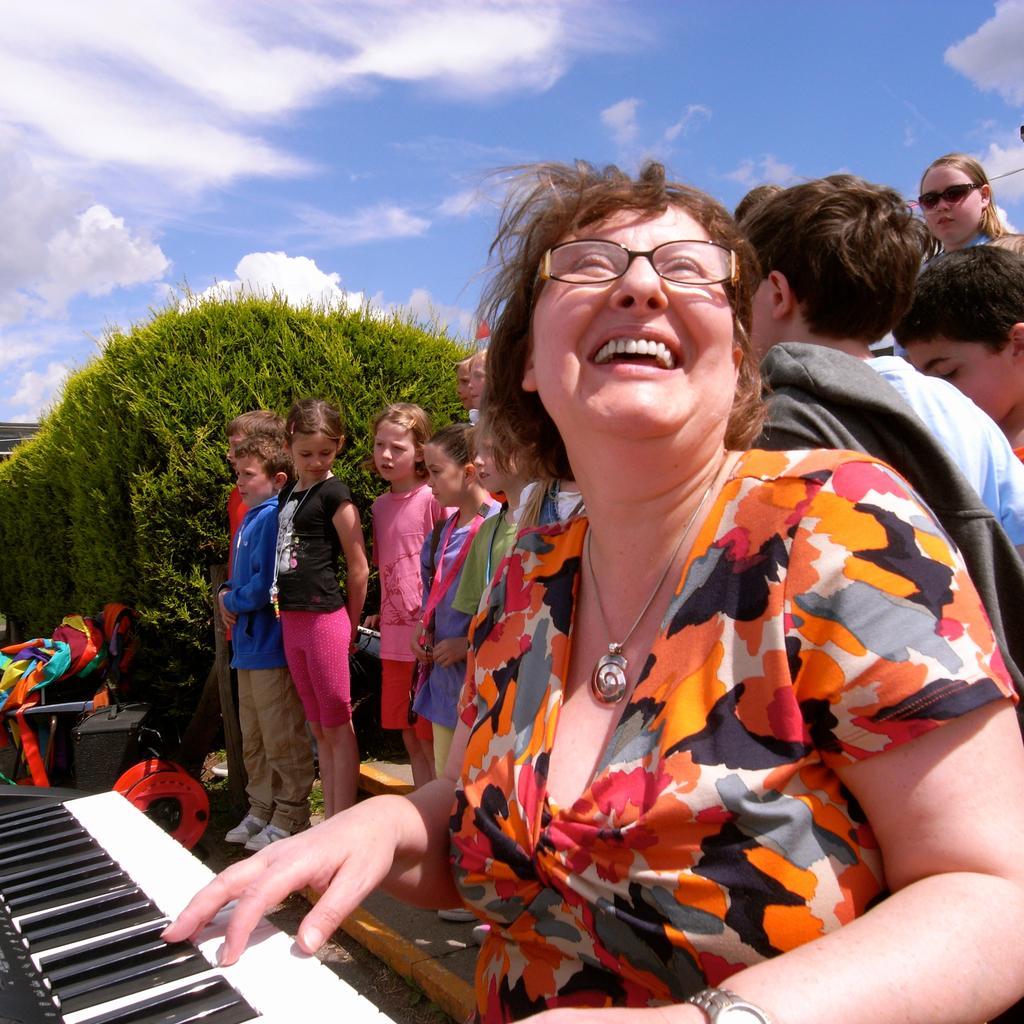Describe this image in one or two sentences. In the image there is a woman playing piano and in background there are many kids and whole left side there are trees and above its sky with clouds. 